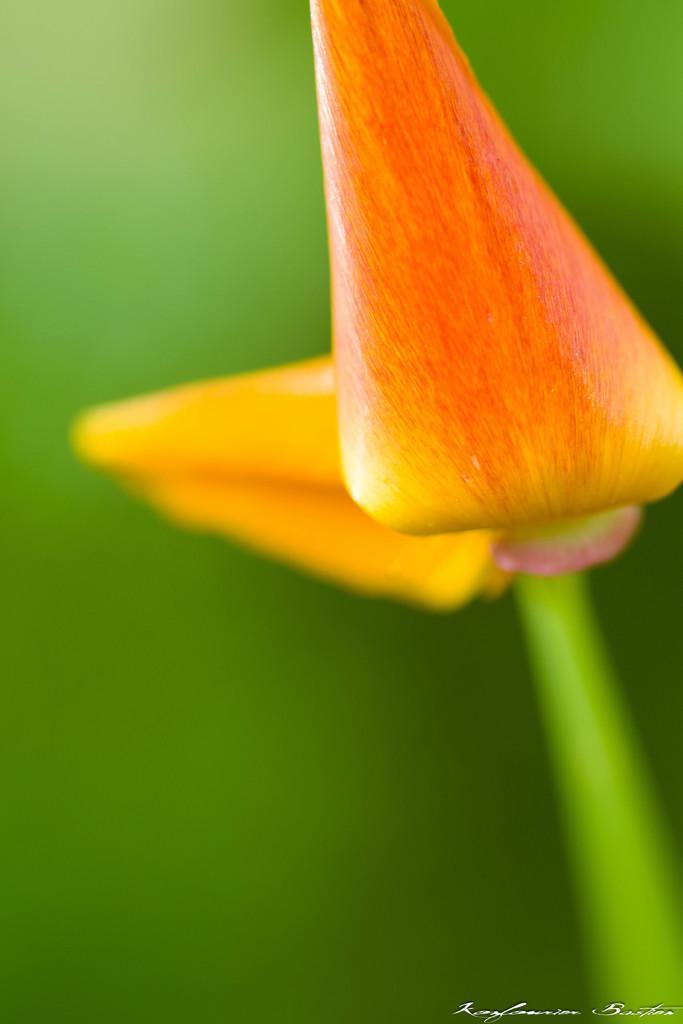Describe this image in one or two sentences. In this image, we can see buds on the green background. 